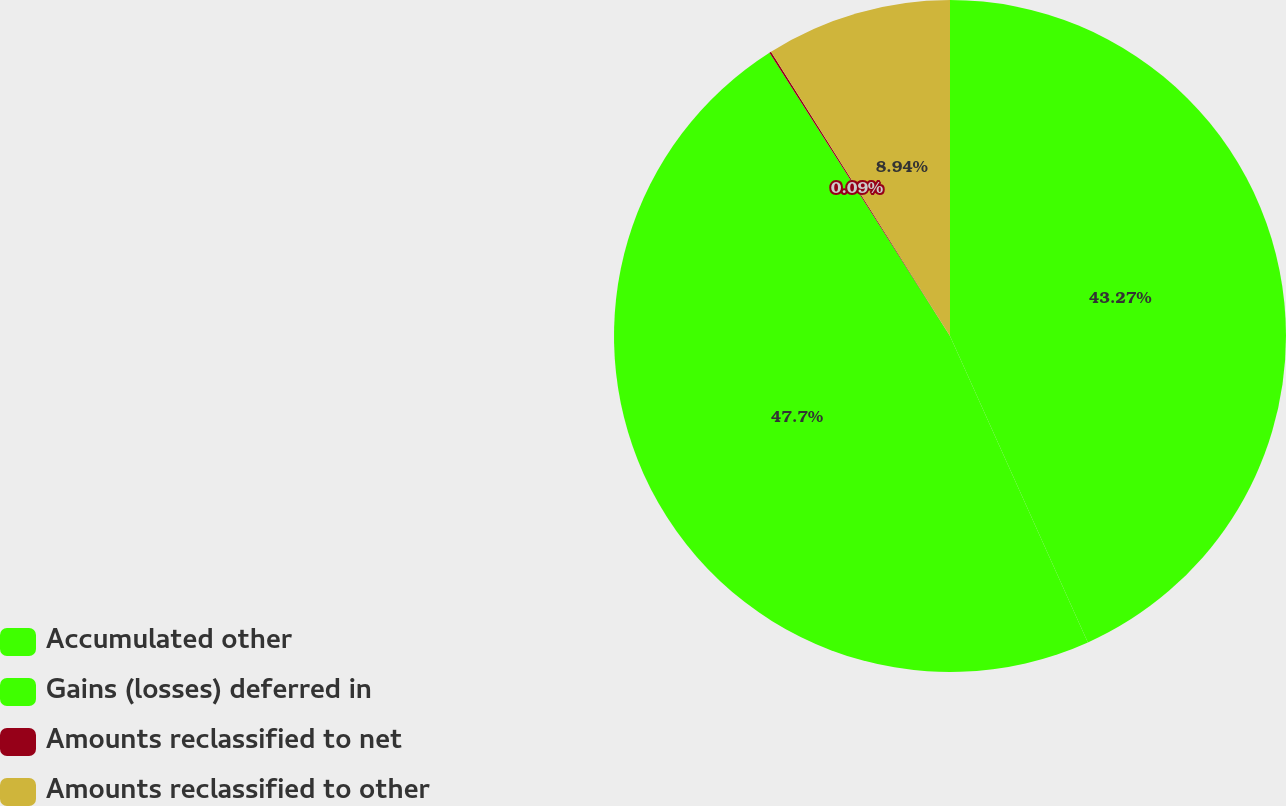Convert chart to OTSL. <chart><loc_0><loc_0><loc_500><loc_500><pie_chart><fcel>Accumulated other<fcel>Gains (losses) deferred in<fcel>Amounts reclassified to net<fcel>Amounts reclassified to other<nl><fcel>43.27%<fcel>47.7%<fcel>0.09%<fcel>8.94%<nl></chart> 